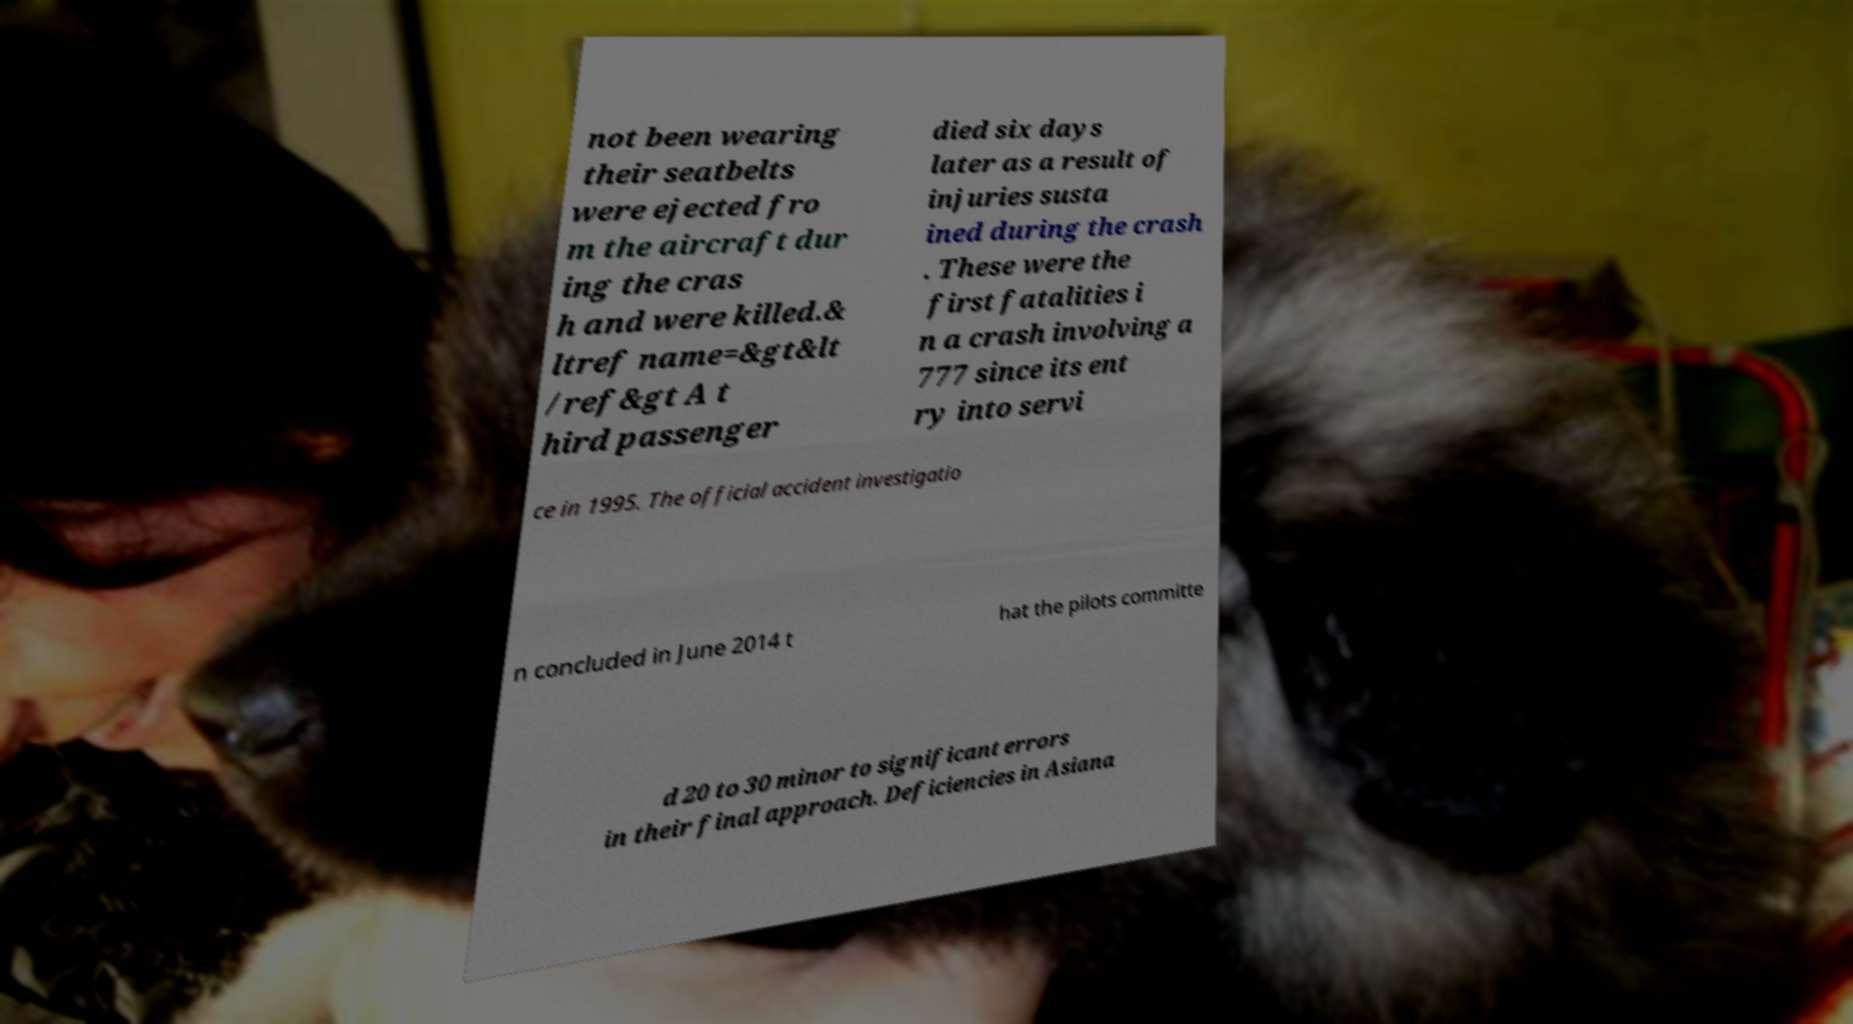I need the written content from this picture converted into text. Can you do that? not been wearing their seatbelts were ejected fro m the aircraft dur ing the cras h and were killed.& ltref name=&gt&lt /ref&gt A t hird passenger died six days later as a result of injuries susta ined during the crash . These were the first fatalities i n a crash involving a 777 since its ent ry into servi ce in 1995. The official accident investigatio n concluded in June 2014 t hat the pilots committe d 20 to 30 minor to significant errors in their final approach. Deficiencies in Asiana 